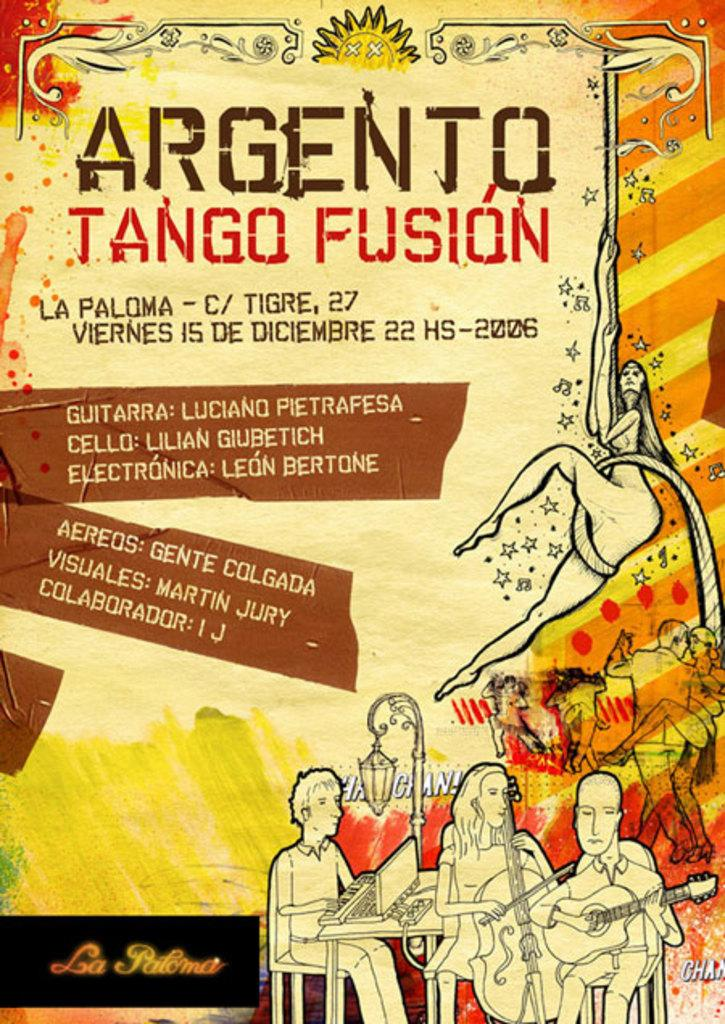Provide a one-sentence caption for the provided image. poster that is yellow, orange, and red with argento tango fusion written at top. 